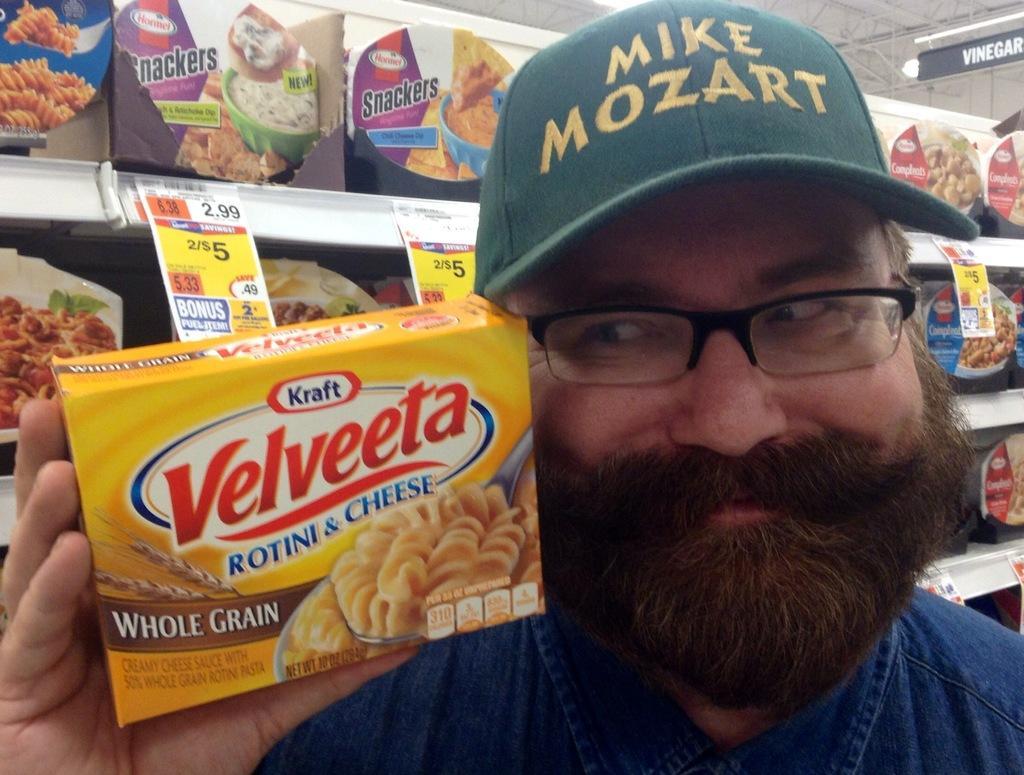Describe this image in one or two sentences. In this image we can see a man holding a packet containing some text and pictures on it. On the backside we can see some packets placed in the racks and some papers pasted on the shelves. On the top right we can see a board with some text on it and a ceiling light to a roof. 